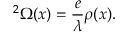Convert formula to latex. <formula><loc_0><loc_0><loc_500><loc_500>{ \nabla } ^ { 2 } \Omega ( x ) = \frac { e } { \lambda } \rho ( x ) .</formula> 